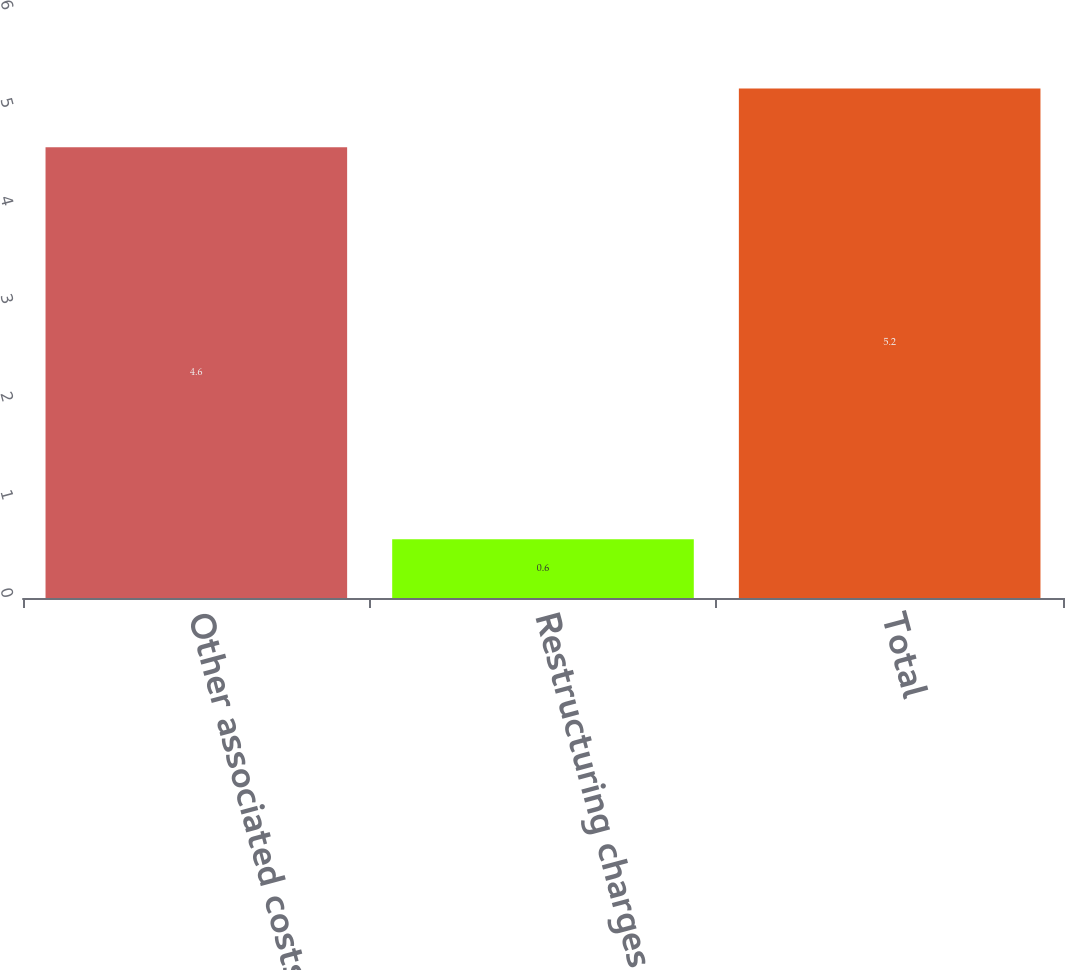<chart> <loc_0><loc_0><loc_500><loc_500><bar_chart><fcel>Other associated costs<fcel>Restructuring charges<fcel>Total<nl><fcel>4.6<fcel>0.6<fcel>5.2<nl></chart> 